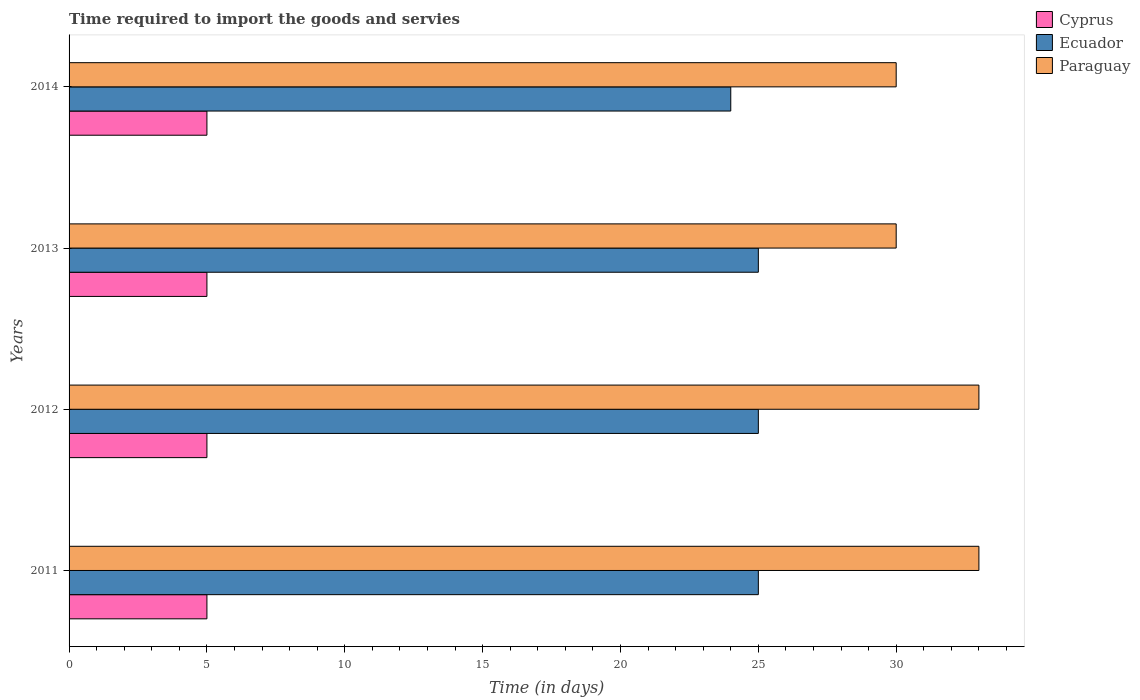How many groups of bars are there?
Your response must be concise. 4. Are the number of bars on each tick of the Y-axis equal?
Give a very brief answer. Yes. What is the number of days required to import the goods and services in Paraguay in 2014?
Offer a terse response. 30. Across all years, what is the maximum number of days required to import the goods and services in Ecuador?
Give a very brief answer. 25. Across all years, what is the minimum number of days required to import the goods and services in Paraguay?
Your answer should be very brief. 30. In which year was the number of days required to import the goods and services in Paraguay maximum?
Offer a very short reply. 2011. What is the total number of days required to import the goods and services in Cyprus in the graph?
Make the answer very short. 20. What is the difference between the number of days required to import the goods and services in Ecuador in 2013 and that in 2014?
Your answer should be very brief. 1. What is the difference between the number of days required to import the goods and services in Ecuador in 2011 and the number of days required to import the goods and services in Paraguay in 2012?
Ensure brevity in your answer.  -8. What is the ratio of the number of days required to import the goods and services in Ecuador in 2012 to that in 2014?
Offer a terse response. 1.04. Is the number of days required to import the goods and services in Paraguay in 2013 less than that in 2014?
Provide a short and direct response. No. What is the difference between the highest and the second highest number of days required to import the goods and services in Ecuador?
Provide a short and direct response. 0. What is the difference between the highest and the lowest number of days required to import the goods and services in Ecuador?
Provide a short and direct response. 1. Is the sum of the number of days required to import the goods and services in Paraguay in 2011 and 2014 greater than the maximum number of days required to import the goods and services in Cyprus across all years?
Your answer should be very brief. Yes. What does the 1st bar from the top in 2014 represents?
Provide a succinct answer. Paraguay. What does the 2nd bar from the bottom in 2014 represents?
Make the answer very short. Ecuador. How many years are there in the graph?
Your answer should be very brief. 4. Does the graph contain grids?
Make the answer very short. No. How many legend labels are there?
Provide a succinct answer. 3. How are the legend labels stacked?
Offer a very short reply. Vertical. What is the title of the graph?
Your answer should be compact. Time required to import the goods and servies. Does "North America" appear as one of the legend labels in the graph?
Make the answer very short. No. What is the label or title of the X-axis?
Keep it short and to the point. Time (in days). What is the Time (in days) in Cyprus in 2011?
Your answer should be very brief. 5. What is the Time (in days) in Ecuador in 2011?
Keep it short and to the point. 25. What is the Time (in days) in Paraguay in 2012?
Offer a terse response. 33. What is the Time (in days) in Cyprus in 2013?
Ensure brevity in your answer.  5. What is the Time (in days) of Paraguay in 2013?
Ensure brevity in your answer.  30. What is the Time (in days) of Cyprus in 2014?
Provide a succinct answer. 5. What is the Time (in days) in Paraguay in 2014?
Offer a very short reply. 30. Across all years, what is the maximum Time (in days) of Cyprus?
Provide a succinct answer. 5. Across all years, what is the maximum Time (in days) of Ecuador?
Keep it short and to the point. 25. Across all years, what is the minimum Time (in days) of Cyprus?
Keep it short and to the point. 5. What is the total Time (in days) of Paraguay in the graph?
Your answer should be compact. 126. What is the difference between the Time (in days) in Cyprus in 2011 and that in 2012?
Ensure brevity in your answer.  0. What is the difference between the Time (in days) of Ecuador in 2011 and that in 2012?
Your answer should be compact. 0. What is the difference between the Time (in days) in Paraguay in 2011 and that in 2012?
Provide a short and direct response. 0. What is the difference between the Time (in days) in Paraguay in 2011 and that in 2013?
Provide a succinct answer. 3. What is the difference between the Time (in days) of Cyprus in 2011 and that in 2014?
Your answer should be very brief. 0. What is the difference between the Time (in days) in Ecuador in 2011 and that in 2014?
Your answer should be compact. 1. What is the difference between the Time (in days) of Paraguay in 2011 and that in 2014?
Your response must be concise. 3. What is the difference between the Time (in days) in Ecuador in 2012 and that in 2013?
Provide a succinct answer. 0. What is the difference between the Time (in days) of Paraguay in 2012 and that in 2013?
Your answer should be compact. 3. What is the difference between the Time (in days) of Cyprus in 2012 and that in 2014?
Provide a short and direct response. 0. What is the difference between the Time (in days) in Ecuador in 2012 and that in 2014?
Give a very brief answer. 1. What is the difference between the Time (in days) in Paraguay in 2012 and that in 2014?
Provide a short and direct response. 3. What is the difference between the Time (in days) of Ecuador in 2013 and that in 2014?
Your answer should be very brief. 1. What is the difference between the Time (in days) of Cyprus in 2011 and the Time (in days) of Paraguay in 2012?
Provide a succinct answer. -28. What is the difference between the Time (in days) in Ecuador in 2011 and the Time (in days) in Paraguay in 2013?
Make the answer very short. -5. What is the difference between the Time (in days) of Cyprus in 2011 and the Time (in days) of Ecuador in 2014?
Give a very brief answer. -19. What is the difference between the Time (in days) in Cyprus in 2011 and the Time (in days) in Paraguay in 2014?
Offer a very short reply. -25. What is the difference between the Time (in days) of Cyprus in 2012 and the Time (in days) of Ecuador in 2014?
Your answer should be compact. -19. What is the difference between the Time (in days) of Ecuador in 2012 and the Time (in days) of Paraguay in 2014?
Ensure brevity in your answer.  -5. What is the difference between the Time (in days) of Ecuador in 2013 and the Time (in days) of Paraguay in 2014?
Your response must be concise. -5. What is the average Time (in days) in Ecuador per year?
Provide a short and direct response. 24.75. What is the average Time (in days) in Paraguay per year?
Provide a short and direct response. 31.5. In the year 2011, what is the difference between the Time (in days) in Cyprus and Time (in days) in Ecuador?
Make the answer very short. -20. In the year 2012, what is the difference between the Time (in days) in Cyprus and Time (in days) in Ecuador?
Your answer should be compact. -20. In the year 2014, what is the difference between the Time (in days) in Ecuador and Time (in days) in Paraguay?
Your answer should be very brief. -6. What is the ratio of the Time (in days) in Ecuador in 2011 to that in 2012?
Provide a short and direct response. 1. What is the ratio of the Time (in days) of Cyprus in 2011 to that in 2013?
Give a very brief answer. 1. What is the ratio of the Time (in days) in Ecuador in 2011 to that in 2013?
Your answer should be very brief. 1. What is the ratio of the Time (in days) of Paraguay in 2011 to that in 2013?
Offer a very short reply. 1.1. What is the ratio of the Time (in days) in Cyprus in 2011 to that in 2014?
Offer a terse response. 1. What is the ratio of the Time (in days) in Ecuador in 2011 to that in 2014?
Provide a succinct answer. 1.04. What is the ratio of the Time (in days) in Ecuador in 2012 to that in 2013?
Ensure brevity in your answer.  1. What is the ratio of the Time (in days) in Ecuador in 2012 to that in 2014?
Give a very brief answer. 1.04. What is the ratio of the Time (in days) of Paraguay in 2012 to that in 2014?
Offer a terse response. 1.1. What is the ratio of the Time (in days) of Cyprus in 2013 to that in 2014?
Your response must be concise. 1. What is the ratio of the Time (in days) of Ecuador in 2013 to that in 2014?
Offer a very short reply. 1.04. What is the difference between the highest and the second highest Time (in days) in Cyprus?
Your response must be concise. 0. What is the difference between the highest and the second highest Time (in days) of Ecuador?
Give a very brief answer. 0. What is the difference between the highest and the lowest Time (in days) of Ecuador?
Your answer should be very brief. 1. What is the difference between the highest and the lowest Time (in days) in Paraguay?
Provide a succinct answer. 3. 